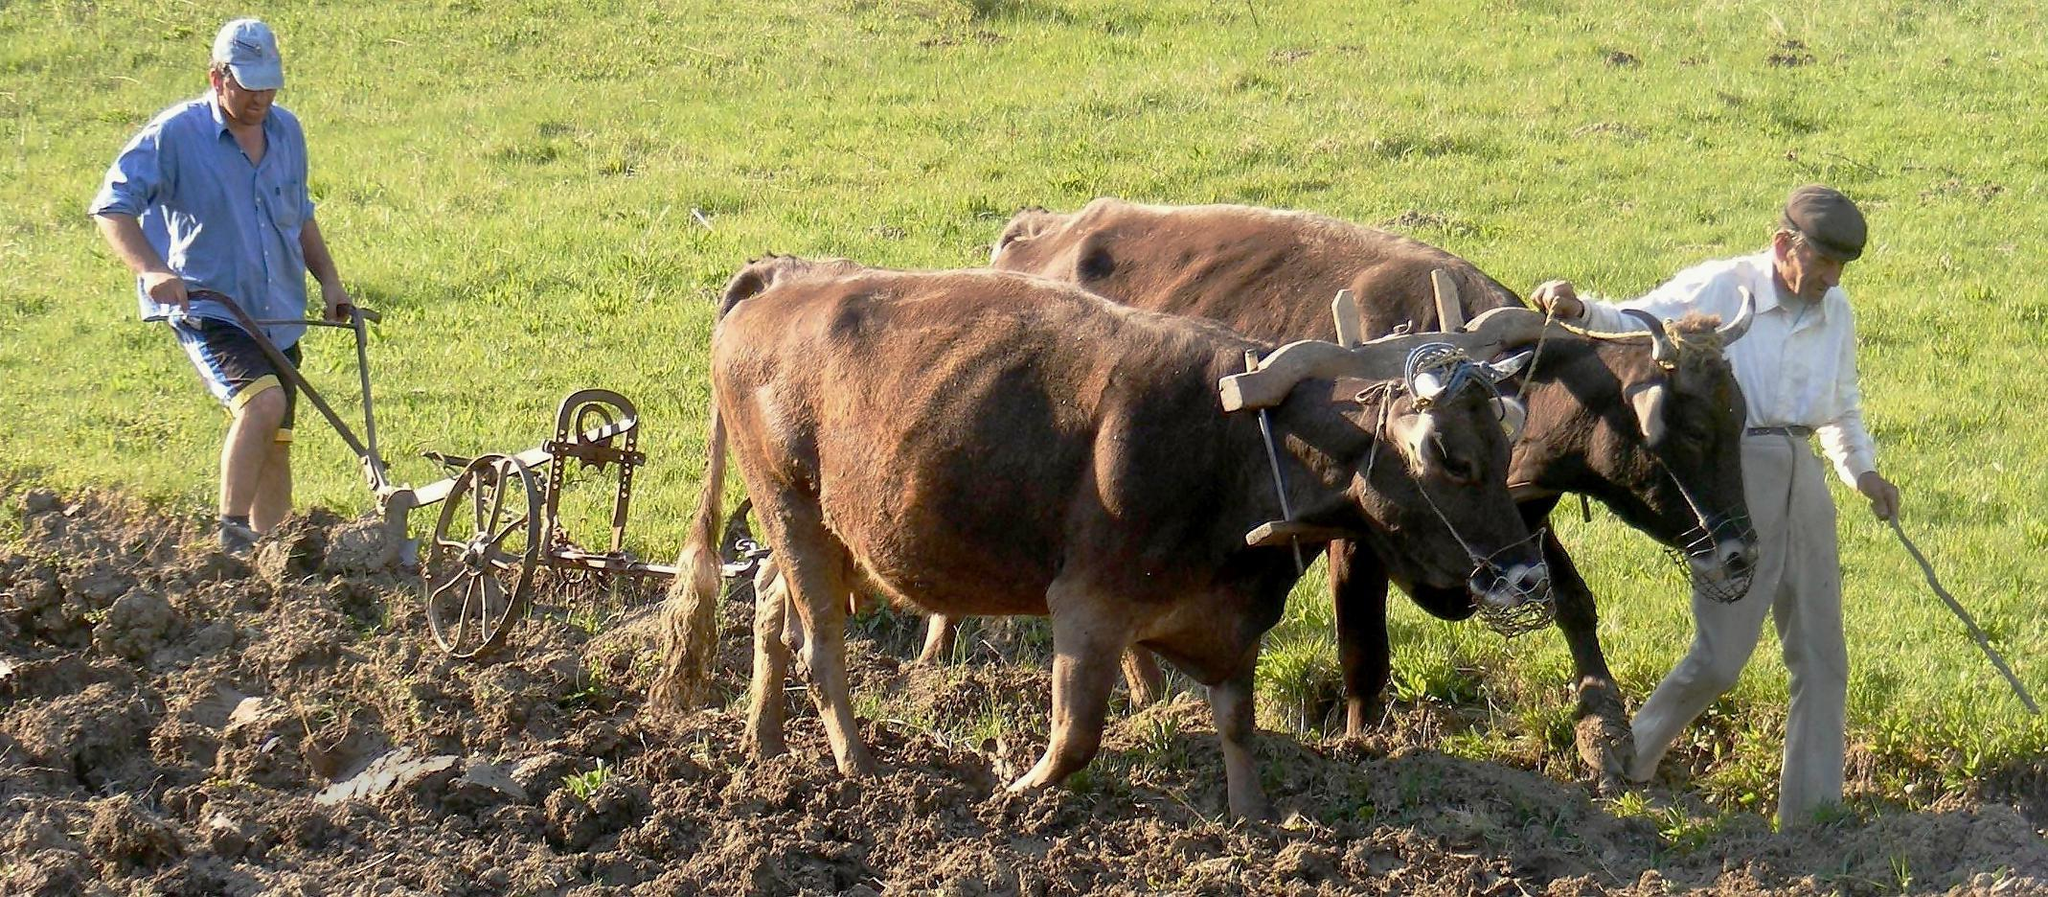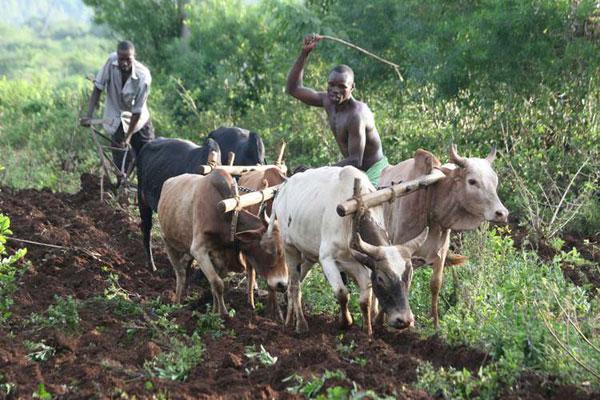The first image is the image on the left, the second image is the image on the right. Assess this claim about the two images: "There are black and brown oxes going right tilting the land as man with a hat follows.". Correct or not? Answer yes or no. No. 